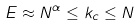Convert formula to latex. <formula><loc_0><loc_0><loc_500><loc_500>E \approx N ^ { \alpha } \leq k _ { c } \leq N</formula> 